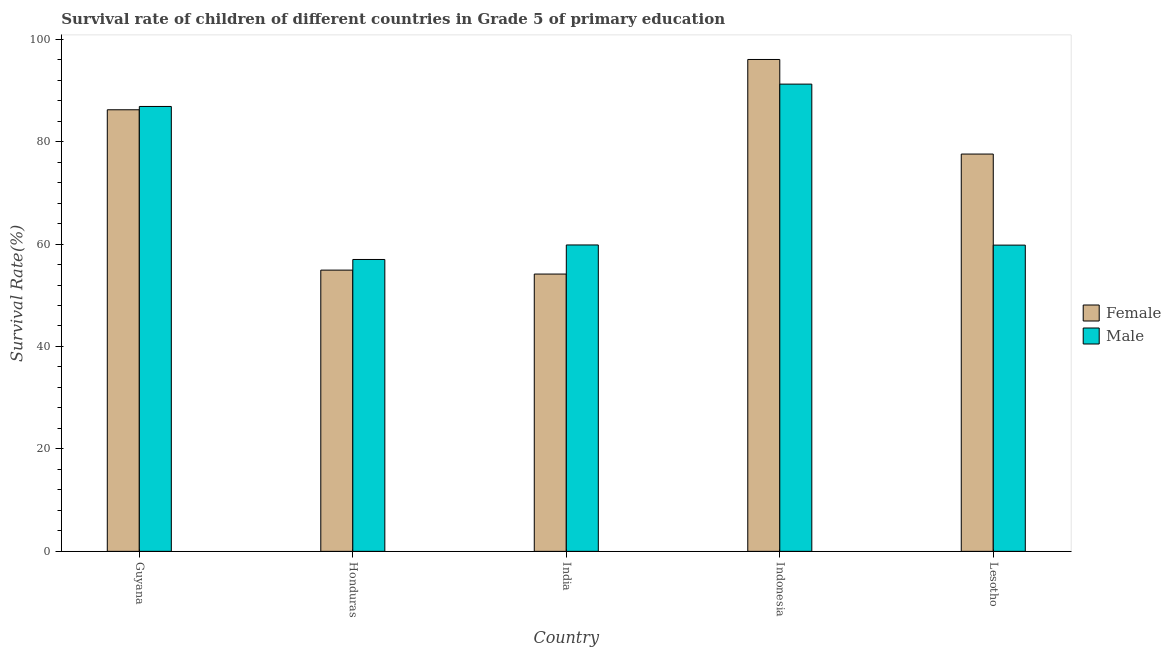Are the number of bars per tick equal to the number of legend labels?
Offer a terse response. Yes. Are the number of bars on each tick of the X-axis equal?
Keep it short and to the point. Yes. How many bars are there on the 1st tick from the left?
Ensure brevity in your answer.  2. How many bars are there on the 1st tick from the right?
Your answer should be very brief. 2. What is the survival rate of female students in primary education in Lesotho?
Offer a terse response. 77.57. Across all countries, what is the maximum survival rate of female students in primary education?
Provide a succinct answer. 96.04. Across all countries, what is the minimum survival rate of male students in primary education?
Keep it short and to the point. 56.99. In which country was the survival rate of male students in primary education maximum?
Offer a terse response. Indonesia. What is the total survival rate of female students in primary education in the graph?
Provide a short and direct response. 368.87. What is the difference between the survival rate of male students in primary education in Guyana and that in Lesotho?
Your answer should be very brief. 27.07. What is the difference between the survival rate of male students in primary education in Indonesia and the survival rate of female students in primary education in India?
Your response must be concise. 37.08. What is the average survival rate of male students in primary education per country?
Keep it short and to the point. 70.94. What is the difference between the survival rate of female students in primary education and survival rate of male students in primary education in Lesotho?
Provide a short and direct response. 17.78. What is the ratio of the survival rate of male students in primary education in India to that in Lesotho?
Give a very brief answer. 1. Is the survival rate of female students in primary education in Honduras less than that in India?
Keep it short and to the point. No. Is the difference between the survival rate of male students in primary education in Guyana and Honduras greater than the difference between the survival rate of female students in primary education in Guyana and Honduras?
Offer a terse response. No. What is the difference between the highest and the second highest survival rate of female students in primary education?
Give a very brief answer. 9.82. What is the difference between the highest and the lowest survival rate of female students in primary education?
Ensure brevity in your answer.  41.9. In how many countries, is the survival rate of male students in primary education greater than the average survival rate of male students in primary education taken over all countries?
Your response must be concise. 2. What does the 2nd bar from the left in Lesotho represents?
Your response must be concise. Male. How many bars are there?
Offer a very short reply. 10. How many countries are there in the graph?
Provide a short and direct response. 5. Does the graph contain any zero values?
Provide a short and direct response. No. Does the graph contain grids?
Give a very brief answer. No. Where does the legend appear in the graph?
Provide a short and direct response. Center right. What is the title of the graph?
Make the answer very short. Survival rate of children of different countries in Grade 5 of primary education. What is the label or title of the X-axis?
Provide a short and direct response. Country. What is the label or title of the Y-axis?
Offer a very short reply. Survival Rate(%). What is the Survival Rate(%) in Female in Guyana?
Provide a succinct answer. 86.21. What is the Survival Rate(%) of Male in Guyana?
Provide a short and direct response. 86.86. What is the Survival Rate(%) of Female in Honduras?
Your response must be concise. 54.91. What is the Survival Rate(%) in Male in Honduras?
Provide a succinct answer. 56.99. What is the Survival Rate(%) in Female in India?
Make the answer very short. 54.14. What is the Survival Rate(%) in Male in India?
Make the answer very short. 59.82. What is the Survival Rate(%) of Female in Indonesia?
Offer a terse response. 96.04. What is the Survival Rate(%) of Male in Indonesia?
Ensure brevity in your answer.  91.22. What is the Survival Rate(%) of Female in Lesotho?
Make the answer very short. 77.57. What is the Survival Rate(%) in Male in Lesotho?
Offer a very short reply. 59.79. Across all countries, what is the maximum Survival Rate(%) in Female?
Ensure brevity in your answer.  96.04. Across all countries, what is the maximum Survival Rate(%) of Male?
Offer a very short reply. 91.22. Across all countries, what is the minimum Survival Rate(%) of Female?
Your answer should be compact. 54.14. Across all countries, what is the minimum Survival Rate(%) in Male?
Your answer should be compact. 56.99. What is the total Survival Rate(%) in Female in the graph?
Give a very brief answer. 368.87. What is the total Survival Rate(%) in Male in the graph?
Your answer should be very brief. 354.68. What is the difference between the Survival Rate(%) in Female in Guyana and that in Honduras?
Provide a short and direct response. 31.3. What is the difference between the Survival Rate(%) of Male in Guyana and that in Honduras?
Ensure brevity in your answer.  29.87. What is the difference between the Survival Rate(%) in Female in Guyana and that in India?
Ensure brevity in your answer.  32.07. What is the difference between the Survival Rate(%) of Male in Guyana and that in India?
Your response must be concise. 27.04. What is the difference between the Survival Rate(%) of Female in Guyana and that in Indonesia?
Your answer should be compact. -9.82. What is the difference between the Survival Rate(%) of Male in Guyana and that in Indonesia?
Offer a terse response. -4.36. What is the difference between the Survival Rate(%) of Female in Guyana and that in Lesotho?
Provide a succinct answer. 8.65. What is the difference between the Survival Rate(%) of Male in Guyana and that in Lesotho?
Make the answer very short. 27.07. What is the difference between the Survival Rate(%) of Female in Honduras and that in India?
Provide a short and direct response. 0.77. What is the difference between the Survival Rate(%) in Male in Honduras and that in India?
Give a very brief answer. -2.83. What is the difference between the Survival Rate(%) in Female in Honduras and that in Indonesia?
Provide a short and direct response. -41.13. What is the difference between the Survival Rate(%) of Male in Honduras and that in Indonesia?
Provide a succinct answer. -34.24. What is the difference between the Survival Rate(%) in Female in Honduras and that in Lesotho?
Your response must be concise. -22.66. What is the difference between the Survival Rate(%) in Male in Honduras and that in Lesotho?
Your answer should be very brief. -2.8. What is the difference between the Survival Rate(%) in Female in India and that in Indonesia?
Offer a very short reply. -41.9. What is the difference between the Survival Rate(%) of Male in India and that in Indonesia?
Provide a succinct answer. -31.4. What is the difference between the Survival Rate(%) in Female in India and that in Lesotho?
Offer a terse response. -23.43. What is the difference between the Survival Rate(%) of Male in India and that in Lesotho?
Your answer should be compact. 0.03. What is the difference between the Survival Rate(%) of Female in Indonesia and that in Lesotho?
Offer a very short reply. 18.47. What is the difference between the Survival Rate(%) of Male in Indonesia and that in Lesotho?
Provide a succinct answer. 31.43. What is the difference between the Survival Rate(%) in Female in Guyana and the Survival Rate(%) in Male in Honduras?
Provide a short and direct response. 29.23. What is the difference between the Survival Rate(%) of Female in Guyana and the Survival Rate(%) of Male in India?
Make the answer very short. 26.39. What is the difference between the Survival Rate(%) of Female in Guyana and the Survival Rate(%) of Male in Indonesia?
Offer a very short reply. -5.01. What is the difference between the Survival Rate(%) of Female in Guyana and the Survival Rate(%) of Male in Lesotho?
Your answer should be compact. 26.42. What is the difference between the Survival Rate(%) of Female in Honduras and the Survival Rate(%) of Male in India?
Offer a terse response. -4.91. What is the difference between the Survival Rate(%) of Female in Honduras and the Survival Rate(%) of Male in Indonesia?
Offer a terse response. -36.31. What is the difference between the Survival Rate(%) of Female in Honduras and the Survival Rate(%) of Male in Lesotho?
Ensure brevity in your answer.  -4.88. What is the difference between the Survival Rate(%) of Female in India and the Survival Rate(%) of Male in Indonesia?
Your response must be concise. -37.08. What is the difference between the Survival Rate(%) of Female in India and the Survival Rate(%) of Male in Lesotho?
Give a very brief answer. -5.65. What is the difference between the Survival Rate(%) in Female in Indonesia and the Survival Rate(%) in Male in Lesotho?
Your answer should be compact. 36.25. What is the average Survival Rate(%) of Female per country?
Your answer should be very brief. 73.77. What is the average Survival Rate(%) in Male per country?
Provide a short and direct response. 70.94. What is the difference between the Survival Rate(%) in Female and Survival Rate(%) in Male in Guyana?
Offer a very short reply. -0.65. What is the difference between the Survival Rate(%) of Female and Survival Rate(%) of Male in Honduras?
Provide a short and direct response. -2.08. What is the difference between the Survival Rate(%) in Female and Survival Rate(%) in Male in India?
Your answer should be very brief. -5.68. What is the difference between the Survival Rate(%) of Female and Survival Rate(%) of Male in Indonesia?
Ensure brevity in your answer.  4.81. What is the difference between the Survival Rate(%) in Female and Survival Rate(%) in Male in Lesotho?
Offer a very short reply. 17.78. What is the ratio of the Survival Rate(%) in Female in Guyana to that in Honduras?
Your answer should be very brief. 1.57. What is the ratio of the Survival Rate(%) in Male in Guyana to that in Honduras?
Provide a short and direct response. 1.52. What is the ratio of the Survival Rate(%) of Female in Guyana to that in India?
Provide a succinct answer. 1.59. What is the ratio of the Survival Rate(%) in Male in Guyana to that in India?
Your answer should be very brief. 1.45. What is the ratio of the Survival Rate(%) of Female in Guyana to that in Indonesia?
Make the answer very short. 0.9. What is the ratio of the Survival Rate(%) in Male in Guyana to that in Indonesia?
Your answer should be compact. 0.95. What is the ratio of the Survival Rate(%) of Female in Guyana to that in Lesotho?
Offer a terse response. 1.11. What is the ratio of the Survival Rate(%) in Male in Guyana to that in Lesotho?
Make the answer very short. 1.45. What is the ratio of the Survival Rate(%) in Female in Honduras to that in India?
Make the answer very short. 1.01. What is the ratio of the Survival Rate(%) of Male in Honduras to that in India?
Offer a terse response. 0.95. What is the ratio of the Survival Rate(%) of Female in Honduras to that in Indonesia?
Ensure brevity in your answer.  0.57. What is the ratio of the Survival Rate(%) in Male in Honduras to that in Indonesia?
Your answer should be very brief. 0.62. What is the ratio of the Survival Rate(%) of Female in Honduras to that in Lesotho?
Provide a succinct answer. 0.71. What is the ratio of the Survival Rate(%) in Male in Honduras to that in Lesotho?
Your answer should be compact. 0.95. What is the ratio of the Survival Rate(%) in Female in India to that in Indonesia?
Your answer should be very brief. 0.56. What is the ratio of the Survival Rate(%) of Male in India to that in Indonesia?
Your answer should be very brief. 0.66. What is the ratio of the Survival Rate(%) of Female in India to that in Lesotho?
Provide a short and direct response. 0.7. What is the ratio of the Survival Rate(%) in Male in India to that in Lesotho?
Provide a succinct answer. 1. What is the ratio of the Survival Rate(%) in Female in Indonesia to that in Lesotho?
Provide a short and direct response. 1.24. What is the ratio of the Survival Rate(%) of Male in Indonesia to that in Lesotho?
Offer a very short reply. 1.53. What is the difference between the highest and the second highest Survival Rate(%) in Female?
Provide a succinct answer. 9.82. What is the difference between the highest and the second highest Survival Rate(%) of Male?
Offer a terse response. 4.36. What is the difference between the highest and the lowest Survival Rate(%) of Female?
Make the answer very short. 41.9. What is the difference between the highest and the lowest Survival Rate(%) of Male?
Offer a very short reply. 34.24. 